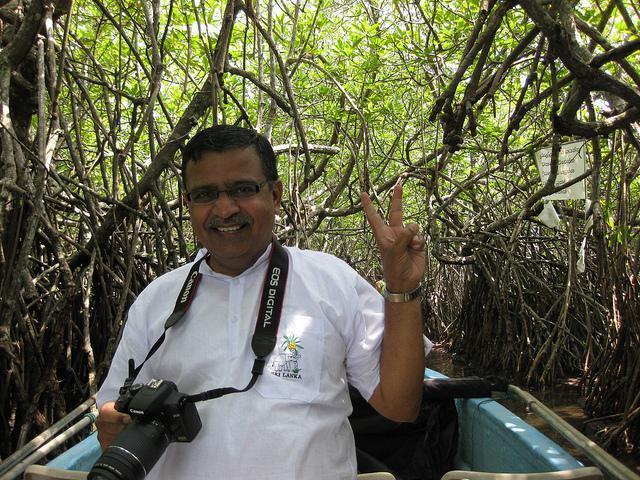How many of the fruit that can be seen in the bowl are bananas?
Give a very brief answer. 0. 